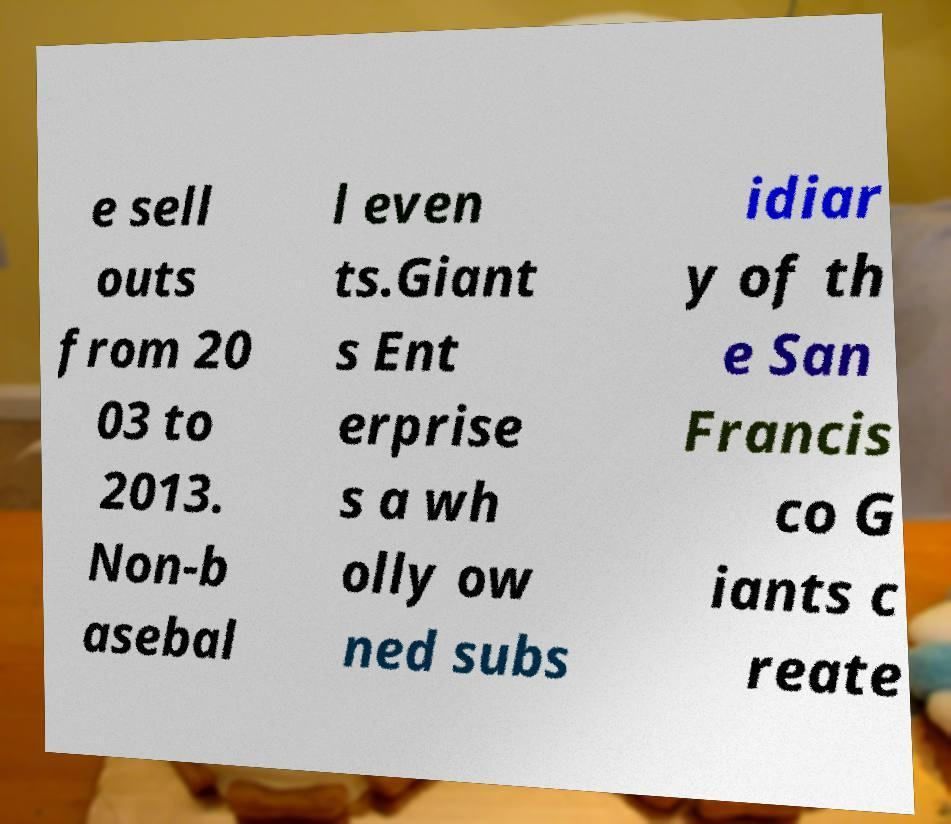There's text embedded in this image that I need extracted. Can you transcribe it verbatim? e sell outs from 20 03 to 2013. Non-b asebal l even ts.Giant s Ent erprise s a wh olly ow ned subs idiar y of th e San Francis co G iants c reate 